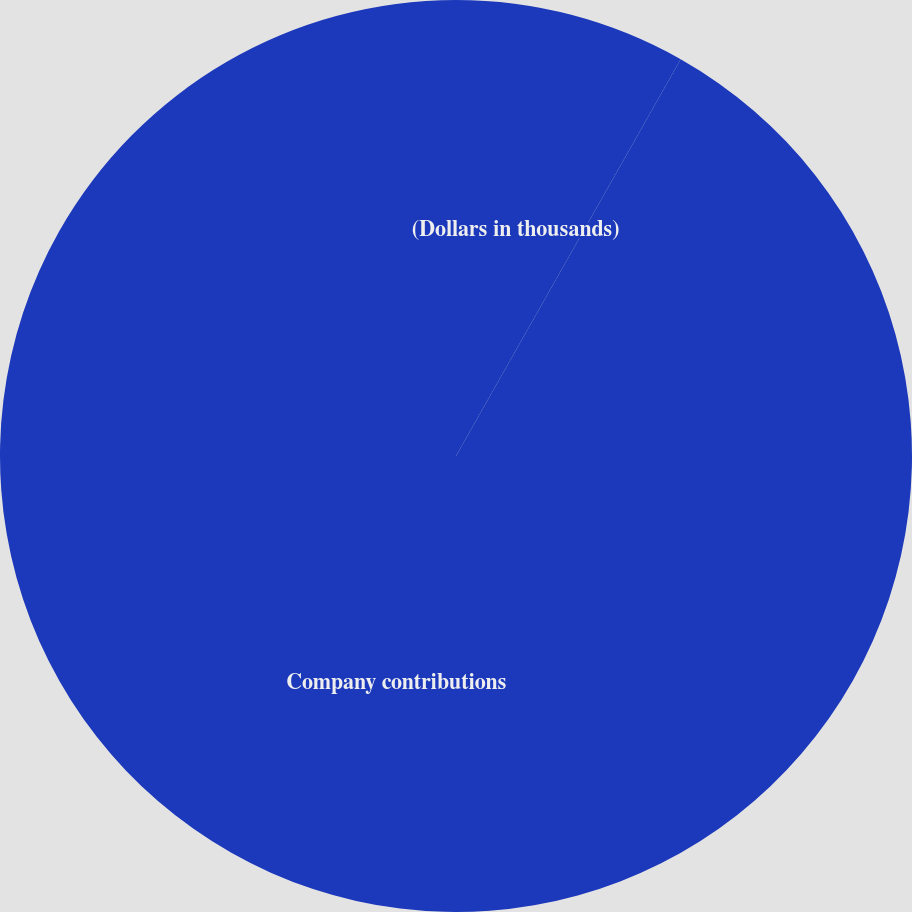Convert chart to OTSL. <chart><loc_0><loc_0><loc_500><loc_500><pie_chart><fcel>(Dollars in thousands)<fcel>Company contributions<nl><fcel>8.2%<fcel>91.8%<nl></chart> 